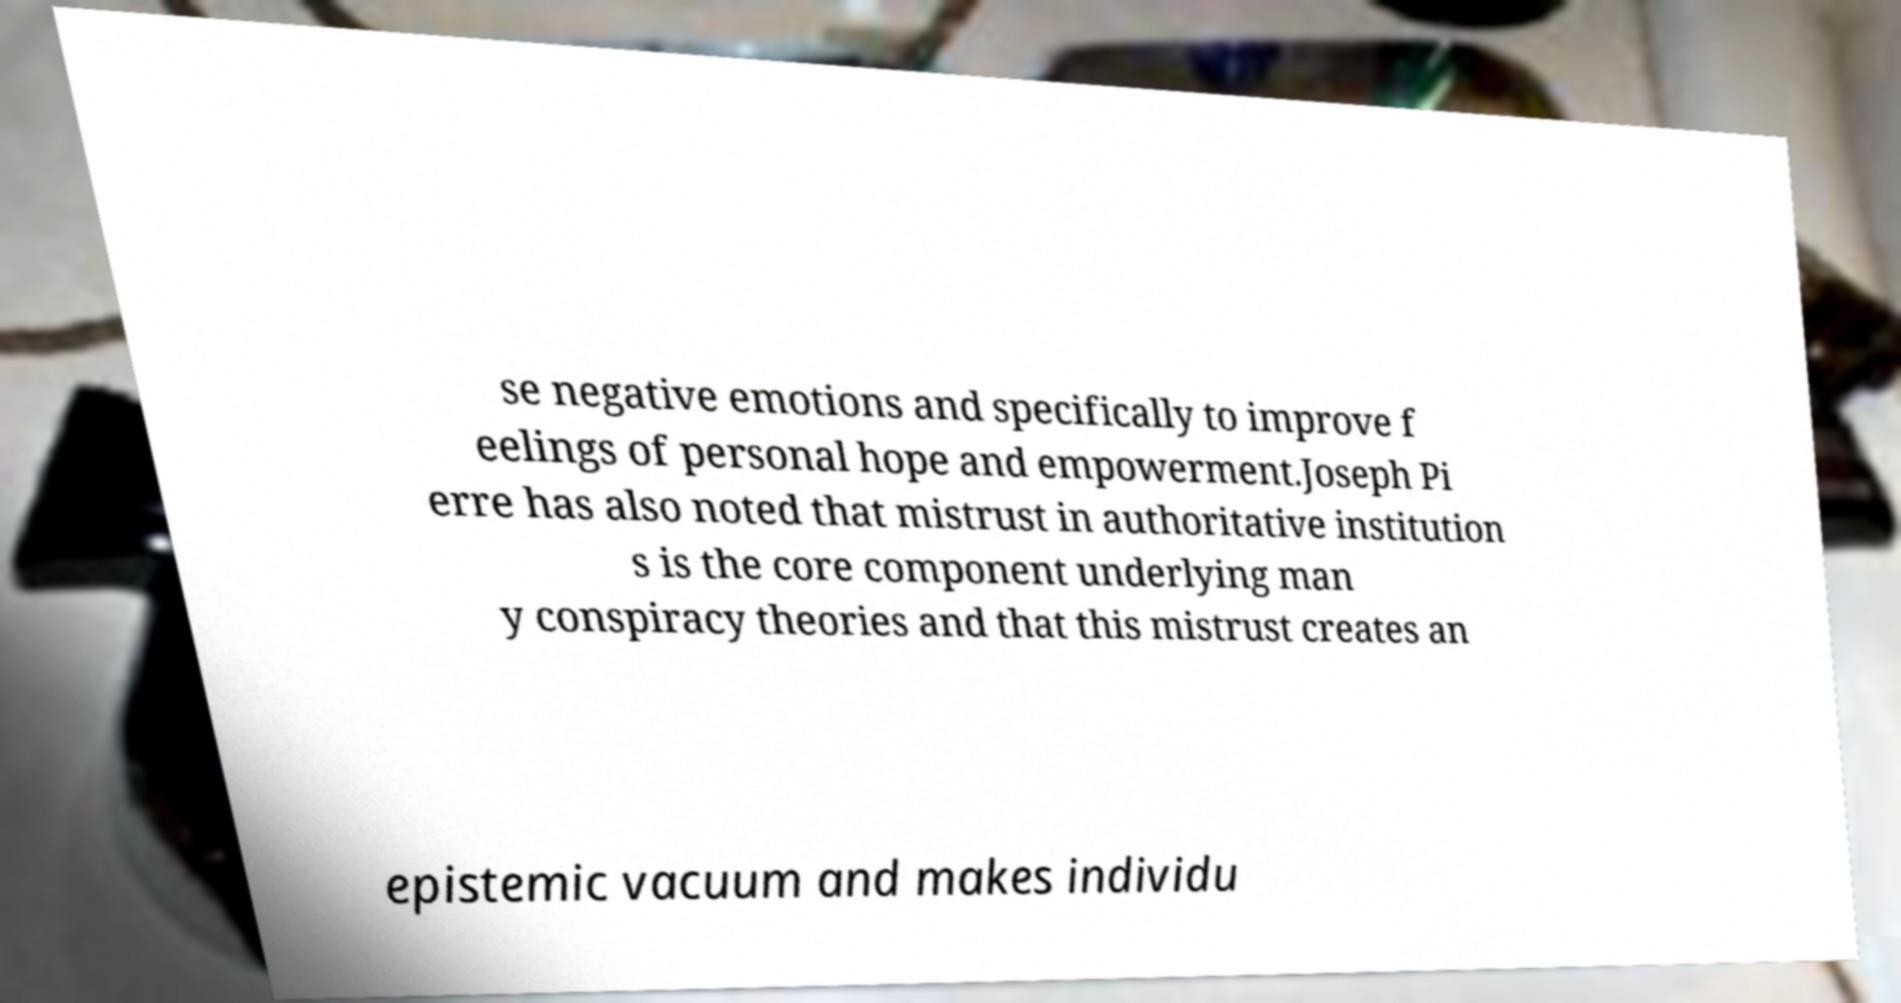There's text embedded in this image that I need extracted. Can you transcribe it verbatim? se negative emotions and specifically to improve f eelings of personal hope and empowerment.Joseph Pi erre has also noted that mistrust in authoritative institution s is the core component underlying man y conspiracy theories and that this mistrust creates an epistemic vacuum and makes individu 